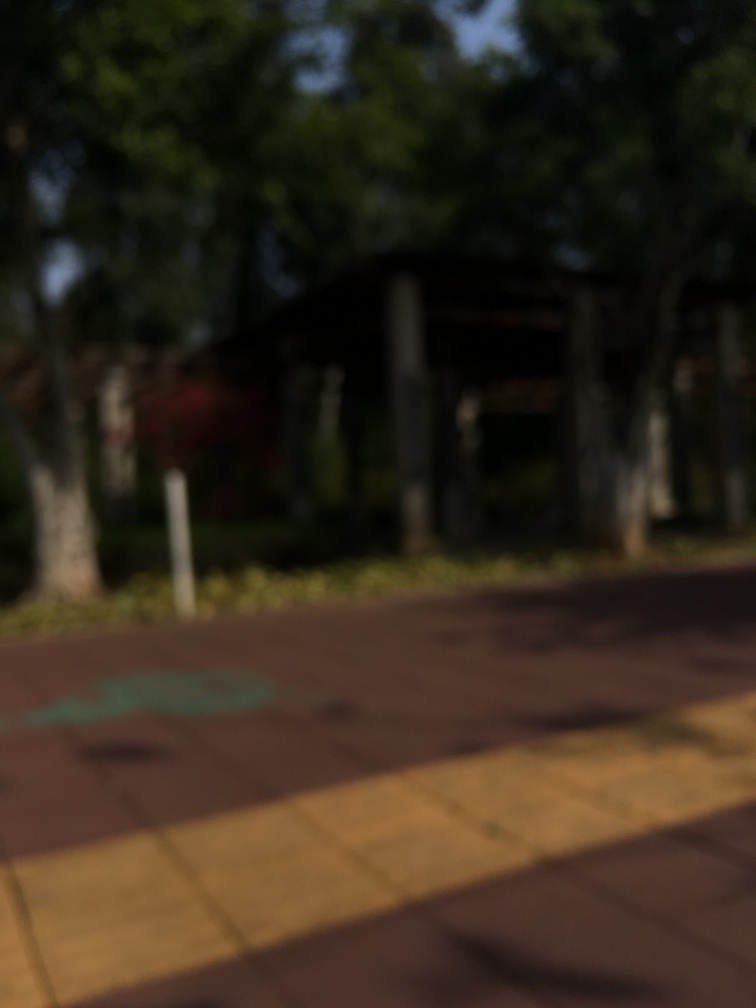Despite the lack of focus, can you speculate what kind of location this image might depict? Although the details are unclear, the general impression suggests an outdoor setting, likely a park or recreational area. We can infer this from the patches of different colors which might represent grassy areas, paths, and foliage. There appears to be some sort of structure in the background that could be part of a playground or sheltered sitting area. What activities might take place in such a setting? In a park or recreational area, one might find people walking, jogging, engaging in sports, children playing, individuals relaxing, and possibly community gatherings or picnics, contributing to the social and leisurely atmosphere generally associated with such locations. 